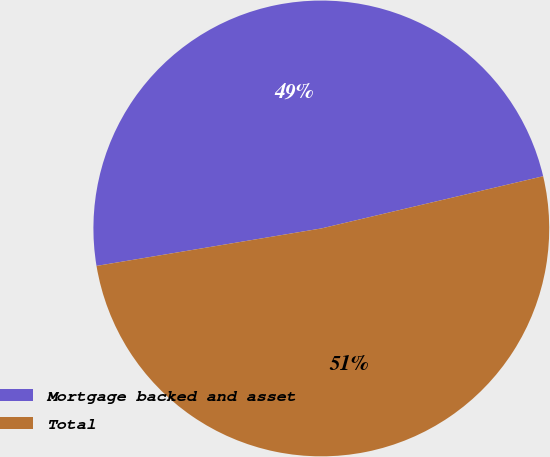<chart> <loc_0><loc_0><loc_500><loc_500><pie_chart><fcel>Mortgage backed and asset<fcel>Total<nl><fcel>48.95%<fcel>51.05%<nl></chart> 